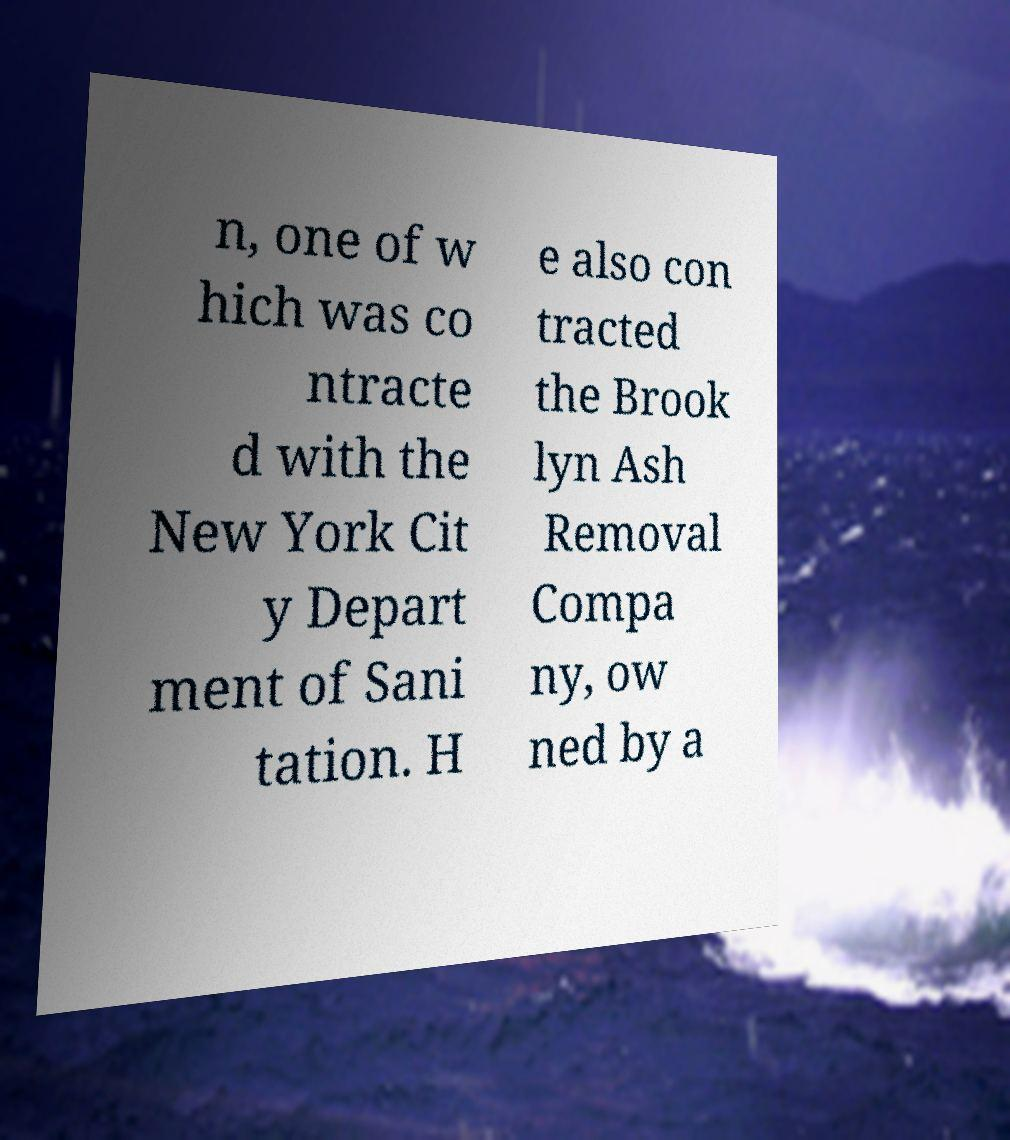What messages or text are displayed in this image? I need them in a readable, typed format. n, one of w hich was co ntracte d with the New York Cit y Depart ment of Sani tation. H e also con tracted the Brook lyn Ash Removal Compa ny, ow ned by a 